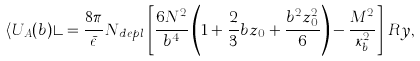<formula> <loc_0><loc_0><loc_500><loc_500>\langle U _ { A } ( b ) \rangle = \frac { 8 \pi } { \bar { \epsilon } } N _ { d e p l } \, \left [ \frac { 6 N ^ { 2 } } { b ^ { 4 } } \left ( 1 + \frac { 2 } { 3 } b z _ { 0 } + \frac { b ^ { 2 } z _ { 0 } ^ { 2 } } { 6 } \right ) - \frac { M ^ { 2 } } { \kappa _ { b } ^ { 2 } } \right ] \, R y ,</formula> 